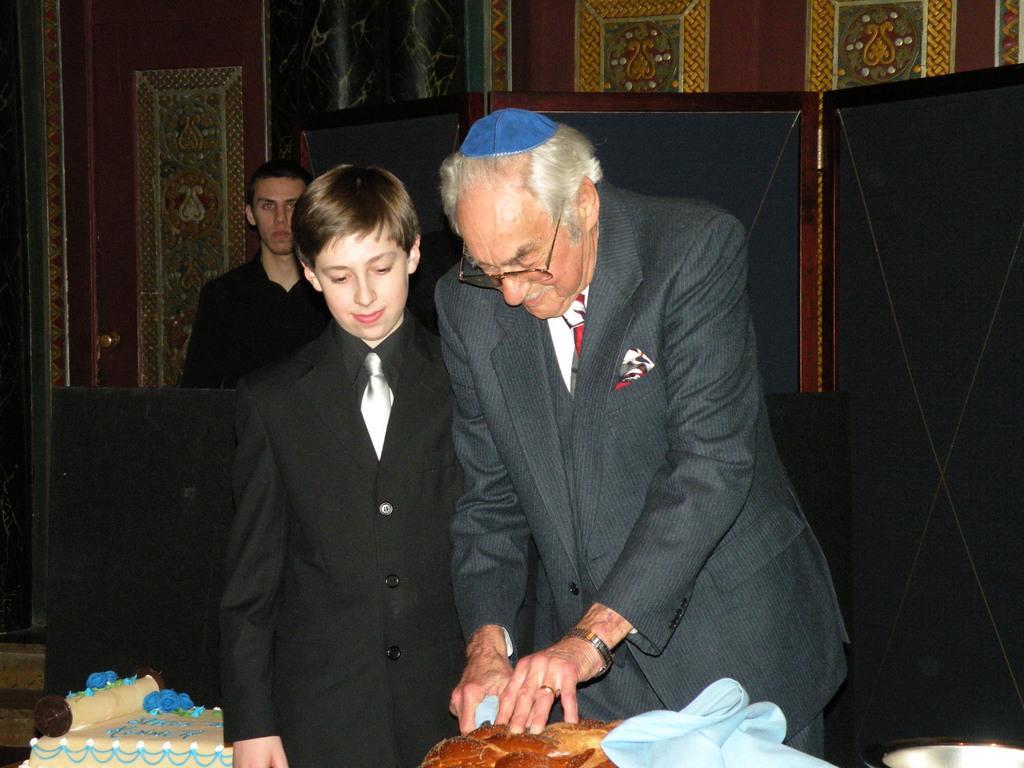Describe this image in one or two sentences. In the center of the image we can see persons standing at the table. On the table we can see cakes. In the background we can see person, door and wall. 